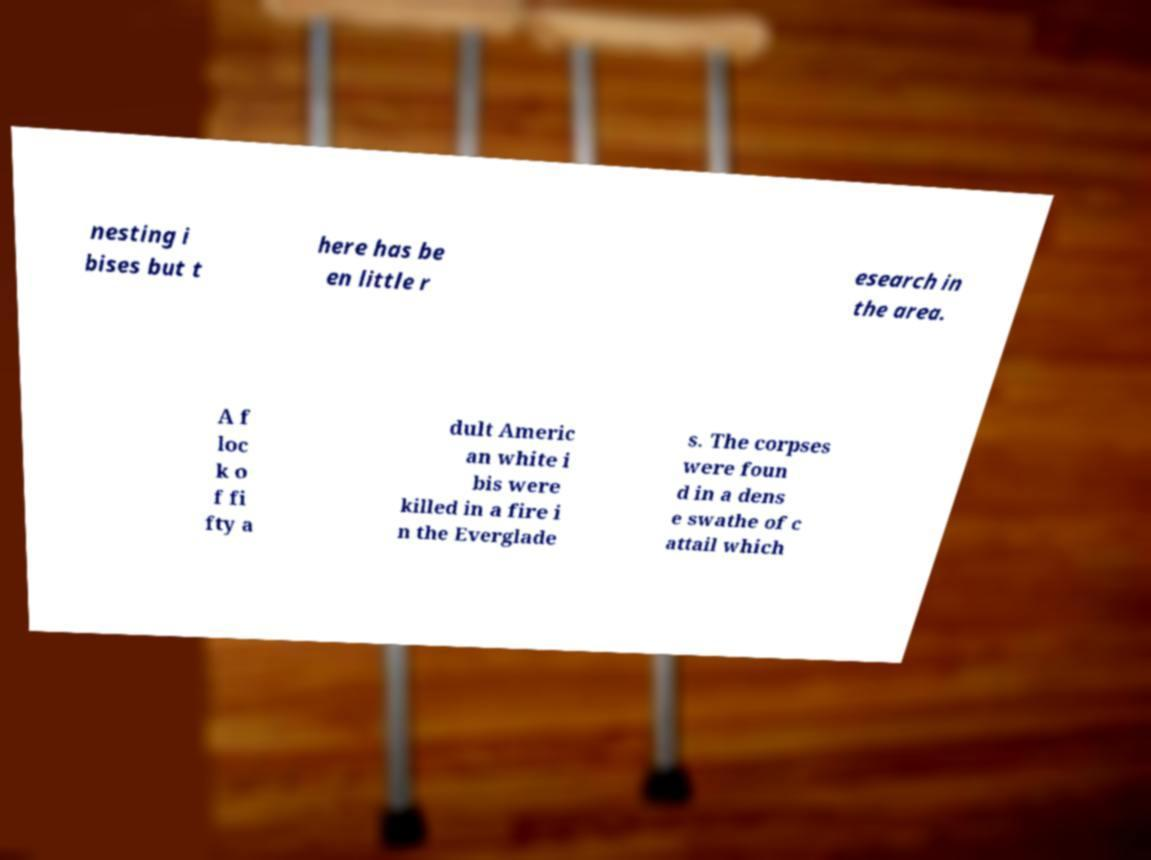There's text embedded in this image that I need extracted. Can you transcribe it verbatim? nesting i bises but t here has be en little r esearch in the area. A f loc k o f fi fty a dult Americ an white i bis were killed in a fire i n the Everglade s. The corpses were foun d in a dens e swathe of c attail which 